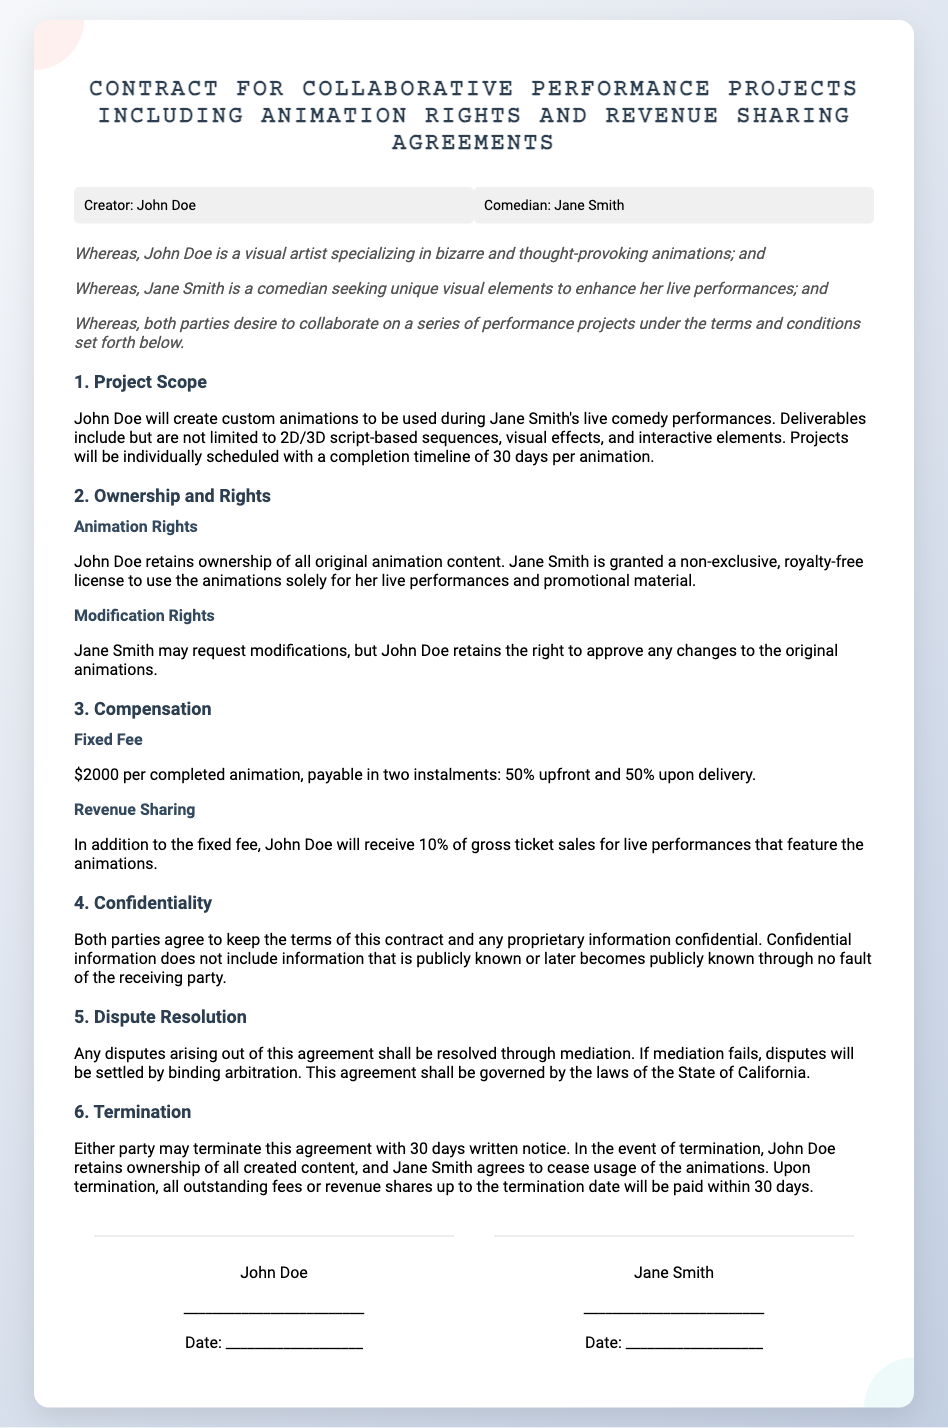What is the name of the creator? The document states that the creator is John Doe.
Answer: John Doe What is the total fixed fee for one completed animation? The fixed fee for a completed animation is explicitly mentioned as $2000.
Answer: $2000 Who will receive a percentage of the ticket sales? The agreement states that John Doe will receive a percentage of the gross ticket sales.
Answer: John Doe What is the percentage of ticket sales John Doe receives? The contract specifies John Doe will receive 10% of gross ticket sales.
Answer: 10% How many days does John Doe have to complete each animation? The document indicates a completion timeline of 30 days per animation.
Answer: 30 days What must Jane Smith do to modify the animations? The contract requires Jane Smith to request modifications, with approval from John Doe.
Answer: Request modifications What type of license does Jane Smith receive for the animations? The contract states that Jane Smith is granted a non-exclusive, royalty-free license.
Answer: Non-exclusive, royalty-free What notice period is required to terminate the agreement? The document specifies that a 30 days written notice is required for termination.
Answer: 30 days Which state's laws govern this contract? The agreement specifies that it is governed by the laws of the State of California.
Answer: California 